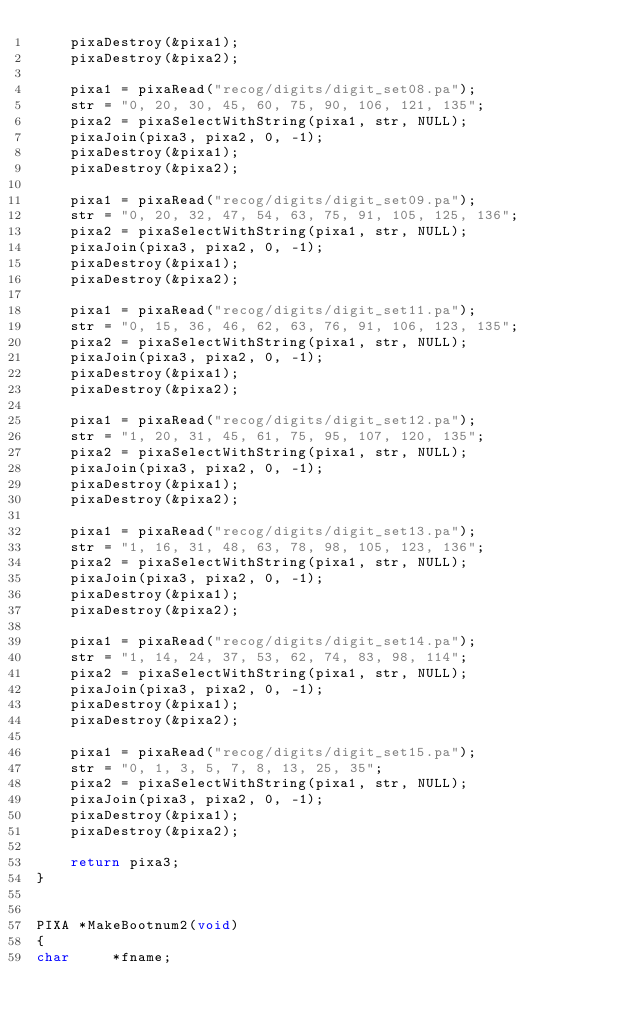Convert code to text. <code><loc_0><loc_0><loc_500><loc_500><_C_>    pixaDestroy(&pixa1);
    pixaDestroy(&pixa2);

    pixa1 = pixaRead("recog/digits/digit_set08.pa");
    str = "0, 20, 30, 45, 60, 75, 90, 106, 121, 135";
    pixa2 = pixaSelectWithString(pixa1, str, NULL);
    pixaJoin(pixa3, pixa2, 0, -1);
    pixaDestroy(&pixa1);
    pixaDestroy(&pixa2);

    pixa1 = pixaRead("recog/digits/digit_set09.pa");
    str = "0, 20, 32, 47, 54, 63, 75, 91, 105, 125, 136";
    pixa2 = pixaSelectWithString(pixa1, str, NULL);
    pixaJoin(pixa3, pixa2, 0, -1);
    pixaDestroy(&pixa1);
    pixaDestroy(&pixa2);

    pixa1 = pixaRead("recog/digits/digit_set11.pa");
    str = "0, 15, 36, 46, 62, 63, 76, 91, 106, 123, 135";
    pixa2 = pixaSelectWithString(pixa1, str, NULL);
    pixaJoin(pixa3, pixa2, 0, -1);
    pixaDestroy(&pixa1);
    pixaDestroy(&pixa2);

    pixa1 = pixaRead("recog/digits/digit_set12.pa");
    str = "1, 20, 31, 45, 61, 75, 95, 107, 120, 135";
    pixa2 = pixaSelectWithString(pixa1, str, NULL);
    pixaJoin(pixa3, pixa2, 0, -1);
    pixaDestroy(&pixa1);
    pixaDestroy(&pixa2);

    pixa1 = pixaRead("recog/digits/digit_set13.pa");
    str = "1, 16, 31, 48, 63, 78, 98, 105, 123, 136";
    pixa2 = pixaSelectWithString(pixa1, str, NULL);
    pixaJoin(pixa3, pixa2, 0, -1);
    pixaDestroy(&pixa1);
    pixaDestroy(&pixa2);

    pixa1 = pixaRead("recog/digits/digit_set14.pa");
    str = "1, 14, 24, 37, 53, 62, 74, 83, 98, 114";
    pixa2 = pixaSelectWithString(pixa1, str, NULL);
    pixaJoin(pixa3, pixa2, 0, -1);
    pixaDestroy(&pixa1);
    pixaDestroy(&pixa2);

    pixa1 = pixaRead("recog/digits/digit_set15.pa");
    str = "0, 1, 3, 5, 7, 8, 13, 25, 35";
    pixa2 = pixaSelectWithString(pixa1, str, NULL);
    pixaJoin(pixa3, pixa2, 0, -1);
    pixaDestroy(&pixa1);
    pixaDestroy(&pixa2);

    return pixa3;
}


PIXA *MakeBootnum2(void)
{
char     *fname;</code> 